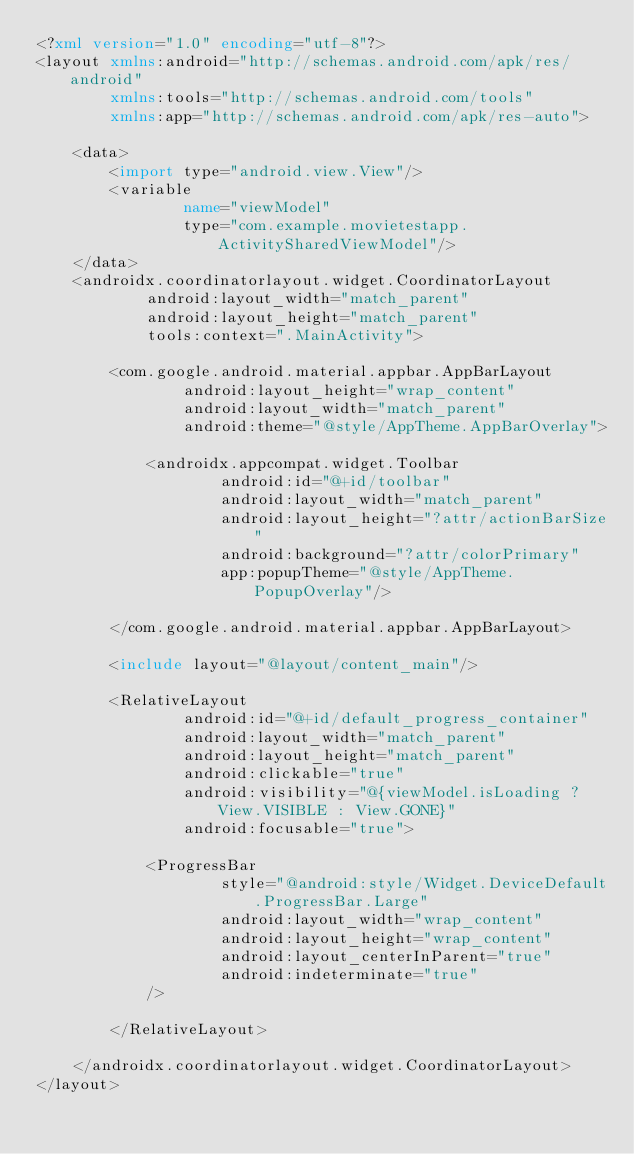<code> <loc_0><loc_0><loc_500><loc_500><_XML_><?xml version="1.0" encoding="utf-8"?>
<layout xmlns:android="http://schemas.android.com/apk/res/android"
        xmlns:tools="http://schemas.android.com/tools"
        xmlns:app="http://schemas.android.com/apk/res-auto">

    <data>
        <import type="android.view.View"/>
        <variable
                name="viewModel"
                type="com.example.movietestapp.ActivitySharedViewModel"/>
    </data>
    <androidx.coordinatorlayout.widget.CoordinatorLayout
            android:layout_width="match_parent"
            android:layout_height="match_parent"
            tools:context=".MainActivity">

        <com.google.android.material.appbar.AppBarLayout
                android:layout_height="wrap_content"
                android:layout_width="match_parent"
                android:theme="@style/AppTheme.AppBarOverlay">

            <androidx.appcompat.widget.Toolbar
                    android:id="@+id/toolbar"
                    android:layout_width="match_parent"
                    android:layout_height="?attr/actionBarSize"
                    android:background="?attr/colorPrimary"
                    app:popupTheme="@style/AppTheme.PopupOverlay"/>

        </com.google.android.material.appbar.AppBarLayout>

        <include layout="@layout/content_main"/>

        <RelativeLayout
                android:id="@+id/default_progress_container"
                android:layout_width="match_parent"
                android:layout_height="match_parent"
                android:clickable="true"
                android:visibility="@{viewModel.isLoading ? View.VISIBLE : View.GONE}"
                android:focusable="true">

            <ProgressBar
                    style="@android:style/Widget.DeviceDefault.ProgressBar.Large"
                    android:layout_width="wrap_content"
                    android:layout_height="wrap_content"
                    android:layout_centerInParent="true"
                    android:indeterminate="true"
            />

        </RelativeLayout>

    </androidx.coordinatorlayout.widget.CoordinatorLayout>
</layout></code> 